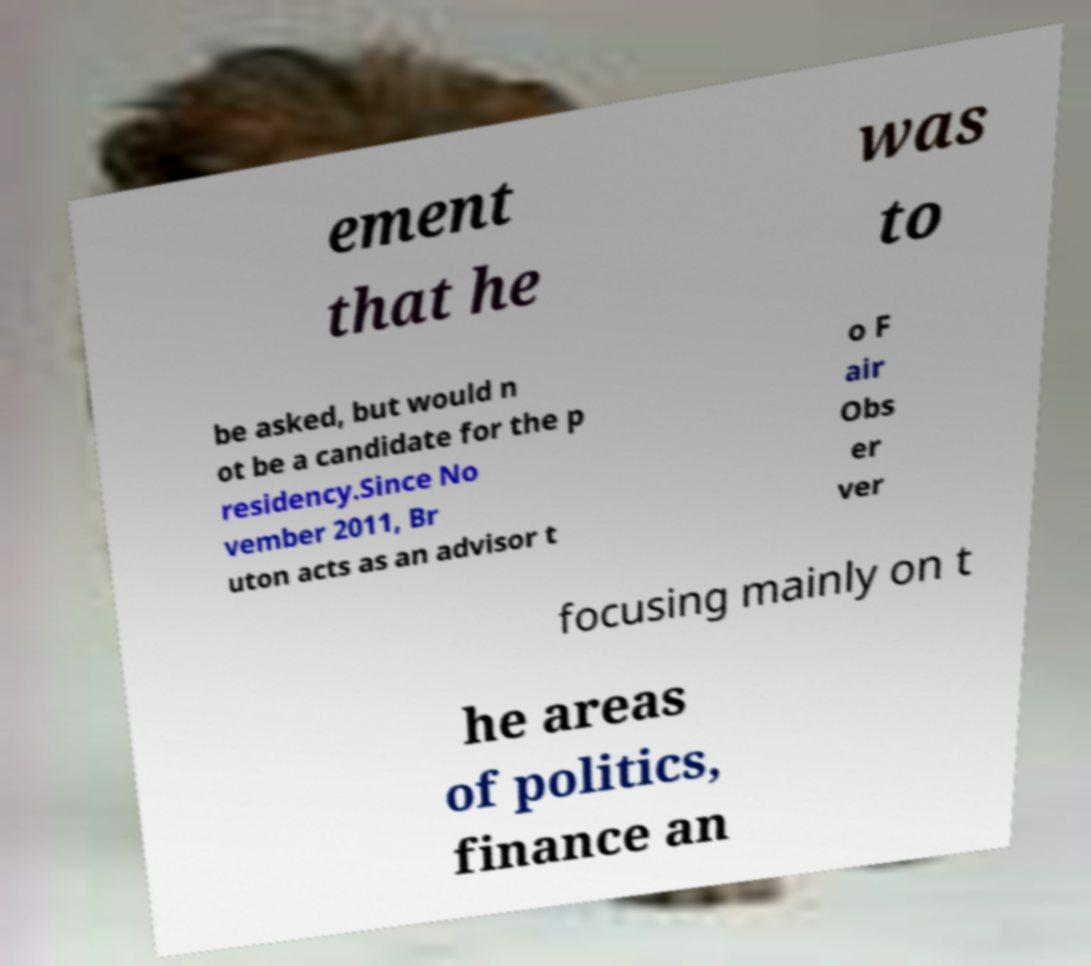Please identify and transcribe the text found in this image. ement that he was to be asked, but would n ot be a candidate for the p residency.Since No vember 2011, Br uton acts as an advisor t o F air Obs er ver focusing mainly on t he areas of politics, finance an 